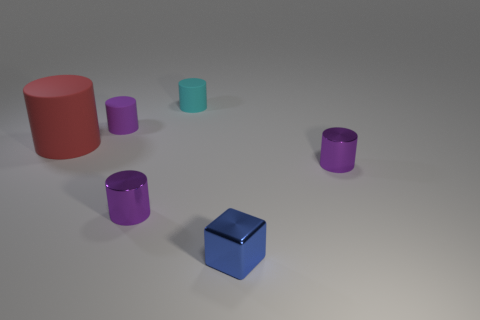Is there any other thing that has the same size as the red matte object?
Give a very brief answer. No. There is a shiny cube; is its size the same as the red thing to the left of the small cyan rubber thing?
Provide a short and direct response. No. There is a red cylinder that is the same material as the cyan thing; what is its size?
Ensure brevity in your answer.  Large. Is the material of the blue object the same as the red cylinder?
Make the answer very short. No. The rubber cylinder on the left side of the small purple thing that is behind the tiny thing that is on the right side of the small block is what color?
Make the answer very short. Red. What is the shape of the blue object?
Your answer should be compact. Cube. Is the number of tiny purple things that are in front of the big object the same as the number of small purple metal cylinders?
Provide a short and direct response. Yes. How many cyan rubber cylinders are the same size as the purple matte cylinder?
Your answer should be very brief. 1. Are there any red shiny cylinders?
Ensure brevity in your answer.  No. There is a purple object behind the large thing; does it have the same shape as the metal object on the right side of the blue thing?
Your response must be concise. Yes. 